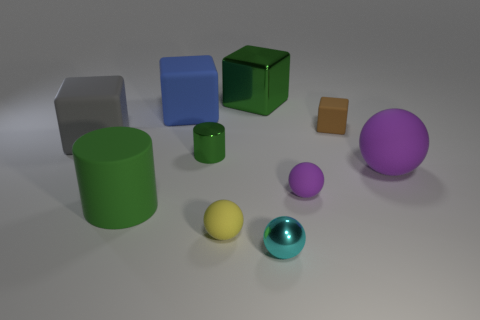What color is the small shiny object on the left side of the cyan ball?
Your response must be concise. Green. Is the color of the shiny cube the same as the shiny object that is left of the big metal cube?
Keep it short and to the point. Yes. Is the number of green rubber cylinders less than the number of blue metal balls?
Provide a short and direct response. No. There is a tiny metal thing on the left side of the small metal ball; is it the same color as the big metallic object?
Your answer should be compact. Yes. What number of gray things are the same size as the yellow rubber object?
Your response must be concise. 0. Are there any tiny matte balls of the same color as the big ball?
Your answer should be compact. Yes. Does the tiny green thing have the same material as the cyan object?
Your response must be concise. Yes. How many other things are the same shape as the big blue object?
Your response must be concise. 3. There is a small thing that is made of the same material as the cyan ball; what is its shape?
Offer a very short reply. Cylinder. There is a small metal object that is behind the sphere that is right of the brown thing; what is its color?
Provide a short and direct response. Green. 